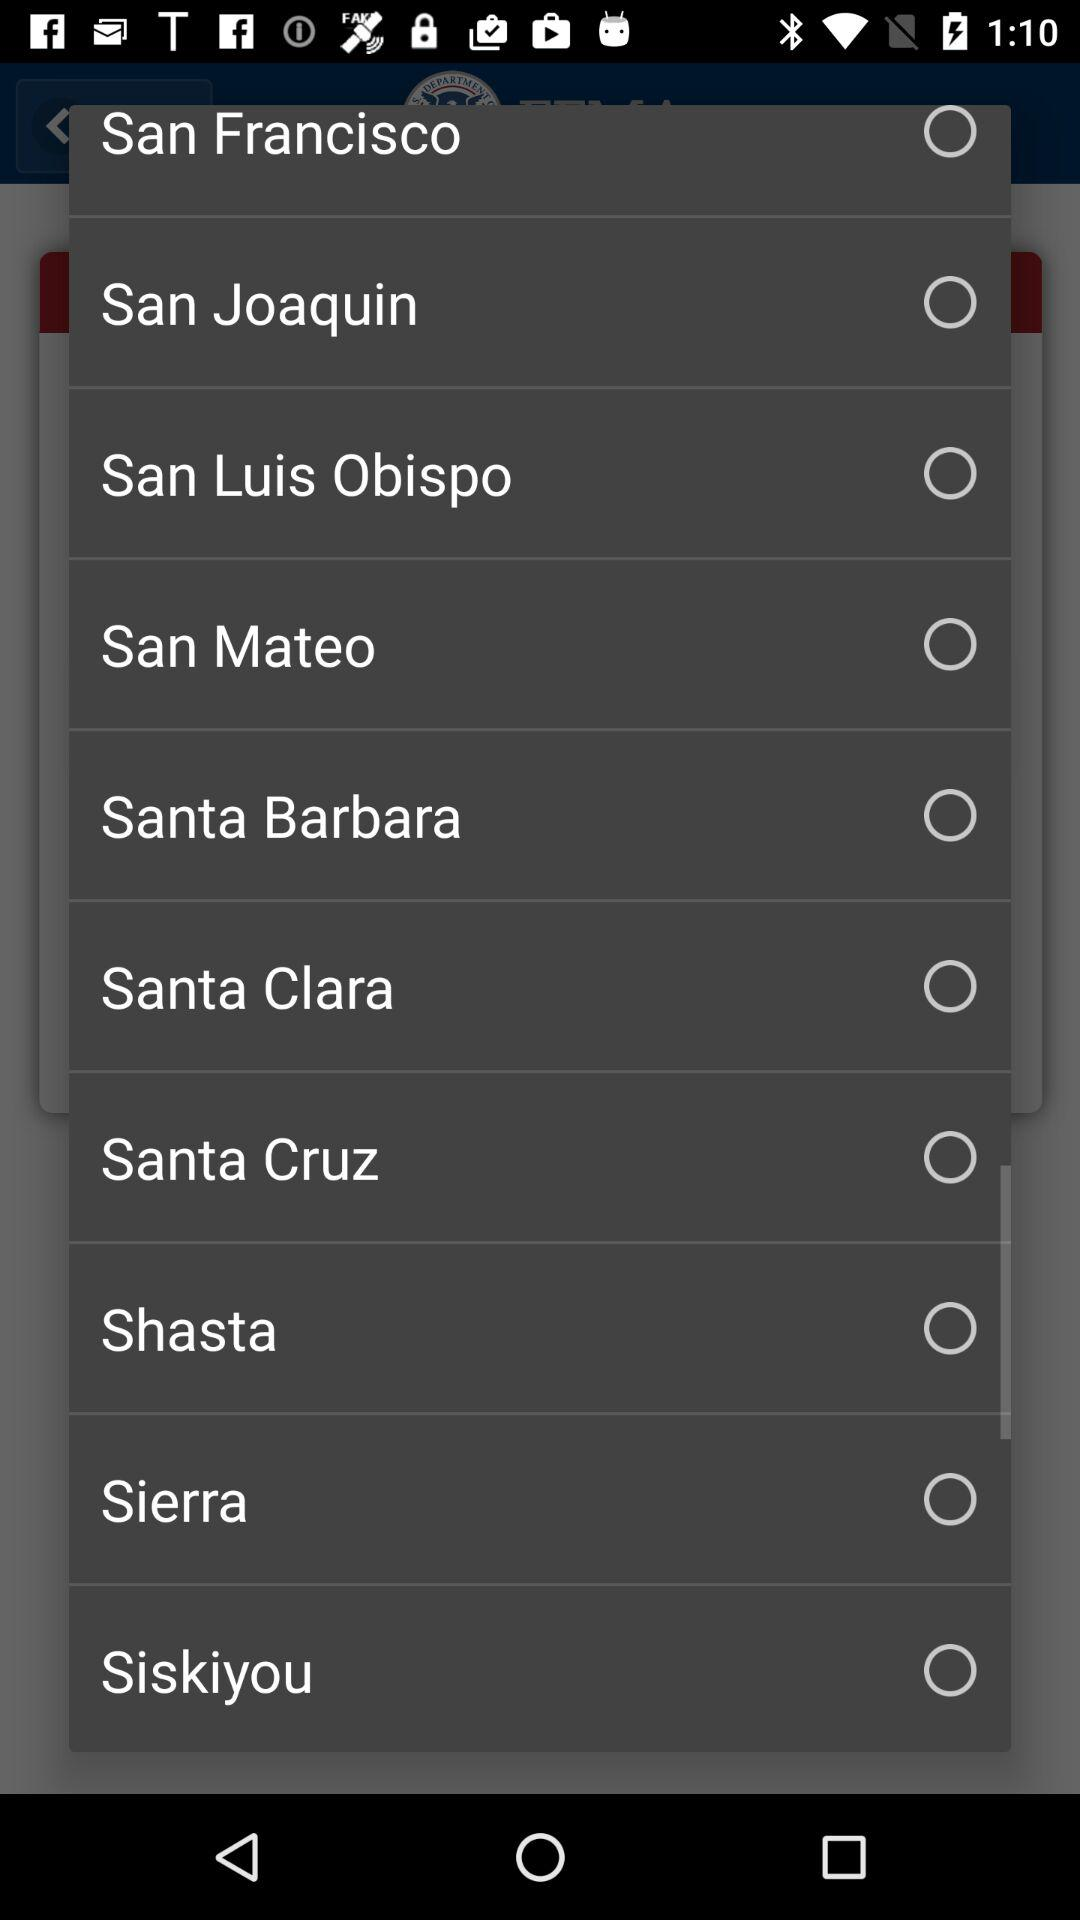How many counties are in California?
Answer the question using a single word or phrase. 10 